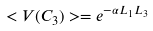<formula> <loc_0><loc_0><loc_500><loc_500>< V ( C _ { 3 } ) > = e ^ { - \alpha L _ { 1 } L _ { 3 } }</formula> 